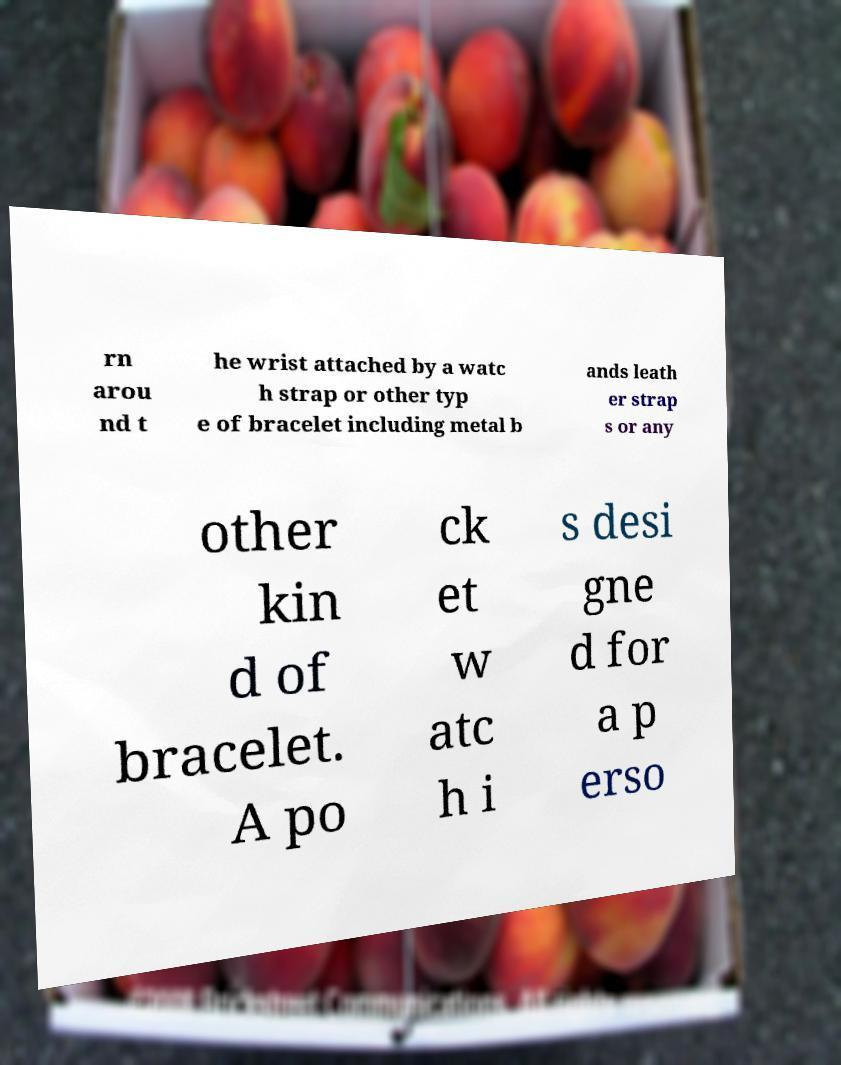What messages or text are displayed in this image? I need them in a readable, typed format. rn arou nd t he wrist attached by a watc h strap or other typ e of bracelet including metal b ands leath er strap s or any other kin d of bracelet. A po ck et w atc h i s desi gne d for a p erso 